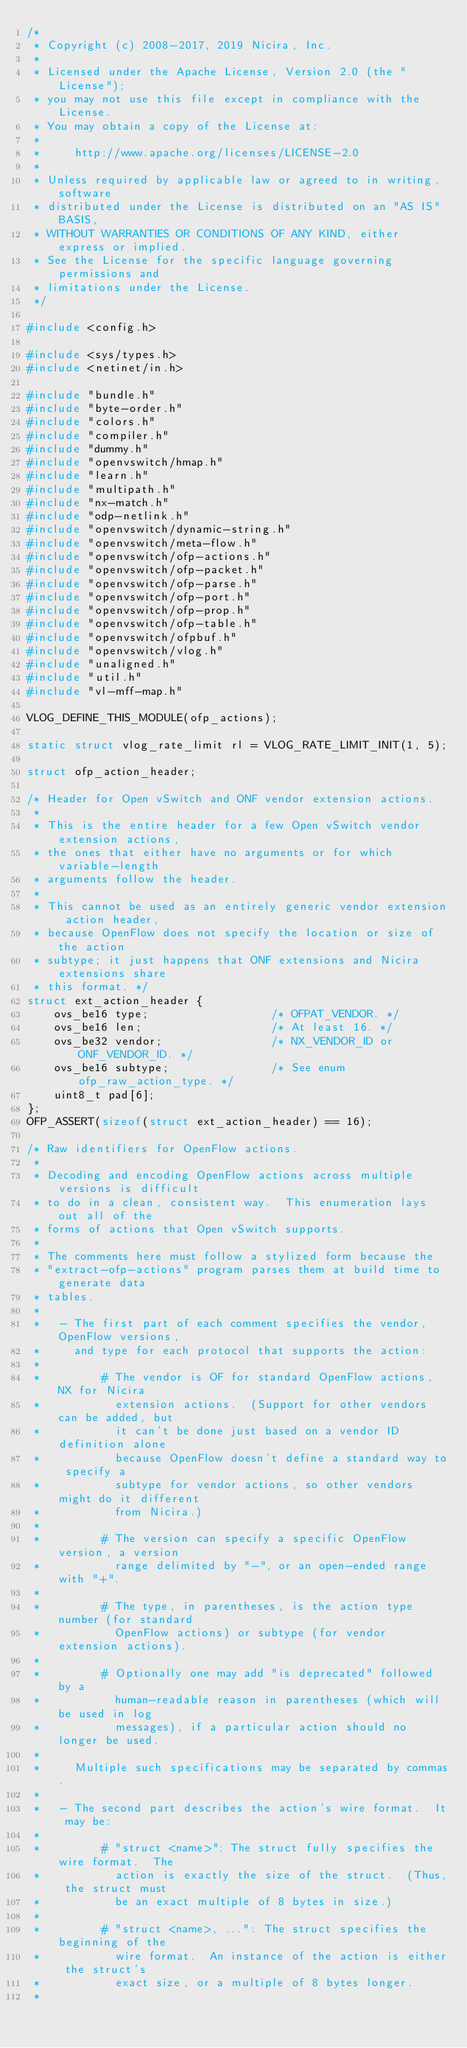<code> <loc_0><loc_0><loc_500><loc_500><_C_>/*
 * Copyright (c) 2008-2017, 2019 Nicira, Inc.
 *
 * Licensed under the Apache License, Version 2.0 (the "License");
 * you may not use this file except in compliance with the License.
 * You may obtain a copy of the License at:
 *
 *     http://www.apache.org/licenses/LICENSE-2.0
 *
 * Unless required by applicable law or agreed to in writing, software
 * distributed under the License is distributed on an "AS IS" BASIS,
 * WITHOUT WARRANTIES OR CONDITIONS OF ANY KIND, either express or implied.
 * See the License for the specific language governing permissions and
 * limitations under the License.
 */

#include <config.h>

#include <sys/types.h>
#include <netinet/in.h>

#include "bundle.h"
#include "byte-order.h"
#include "colors.h"
#include "compiler.h"
#include "dummy.h"
#include "openvswitch/hmap.h"
#include "learn.h"
#include "multipath.h"
#include "nx-match.h"
#include "odp-netlink.h"
#include "openvswitch/dynamic-string.h"
#include "openvswitch/meta-flow.h"
#include "openvswitch/ofp-actions.h"
#include "openvswitch/ofp-packet.h"
#include "openvswitch/ofp-parse.h"
#include "openvswitch/ofp-port.h"
#include "openvswitch/ofp-prop.h"
#include "openvswitch/ofp-table.h"
#include "openvswitch/ofpbuf.h"
#include "openvswitch/vlog.h"
#include "unaligned.h"
#include "util.h"
#include "vl-mff-map.h"

VLOG_DEFINE_THIS_MODULE(ofp_actions);

static struct vlog_rate_limit rl = VLOG_RATE_LIMIT_INIT(1, 5);

struct ofp_action_header;

/* Header for Open vSwitch and ONF vendor extension actions.
 *
 * This is the entire header for a few Open vSwitch vendor extension actions,
 * the ones that either have no arguments or for which variable-length
 * arguments follow the header.
 *
 * This cannot be used as an entirely generic vendor extension action header,
 * because OpenFlow does not specify the location or size of the action
 * subtype; it just happens that ONF extensions and Nicira extensions share
 * this format. */
struct ext_action_header {
    ovs_be16 type;                  /* OFPAT_VENDOR. */
    ovs_be16 len;                   /* At least 16. */
    ovs_be32 vendor;                /* NX_VENDOR_ID or ONF_VENDOR_ID. */
    ovs_be16 subtype;               /* See enum ofp_raw_action_type. */
    uint8_t pad[6];
};
OFP_ASSERT(sizeof(struct ext_action_header) == 16);

/* Raw identifiers for OpenFlow actions.
 *
 * Decoding and encoding OpenFlow actions across multiple versions is difficult
 * to do in a clean, consistent way.  This enumeration lays out all of the
 * forms of actions that Open vSwitch supports.
 *
 * The comments here must follow a stylized form because the
 * "extract-ofp-actions" program parses them at build time to generate data
 * tables.
 *
 *   - The first part of each comment specifies the vendor, OpenFlow versions,
 *     and type for each protocol that supports the action:
 *
 *         # The vendor is OF for standard OpenFlow actions, NX for Nicira
 *           extension actions.  (Support for other vendors can be added, but
 *           it can't be done just based on a vendor ID definition alone
 *           because OpenFlow doesn't define a standard way to specify a
 *           subtype for vendor actions, so other vendors might do it different
 *           from Nicira.)
 *
 *         # The version can specify a specific OpenFlow version, a version
 *           range delimited by "-", or an open-ended range with "+".
 *
 *         # The type, in parentheses, is the action type number (for standard
 *           OpenFlow actions) or subtype (for vendor extension actions).
 *
 *         # Optionally one may add "is deprecated" followed by a
 *           human-readable reason in parentheses (which will be used in log
 *           messages), if a particular action should no longer be used.
 *
 *     Multiple such specifications may be separated by commas.
 *
 *   - The second part describes the action's wire format.  It may be:
 *
 *         # "struct <name>": The struct fully specifies the wire format.  The
 *           action is exactly the size of the struct.  (Thus, the struct must
 *           be an exact multiple of 8 bytes in size.)
 *
 *         # "struct <name>, ...": The struct specifies the beginning of the
 *           wire format.  An instance of the action is either the struct's
 *           exact size, or a multiple of 8 bytes longer.
 *</code> 